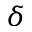Convert formula to latex. <formula><loc_0><loc_0><loc_500><loc_500>\delta</formula> 